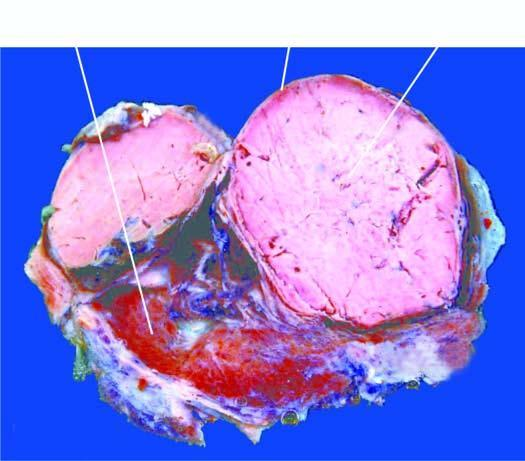what shows a solitary nodule having capsule?
Answer the question using a single word or phrase. Epidermis 